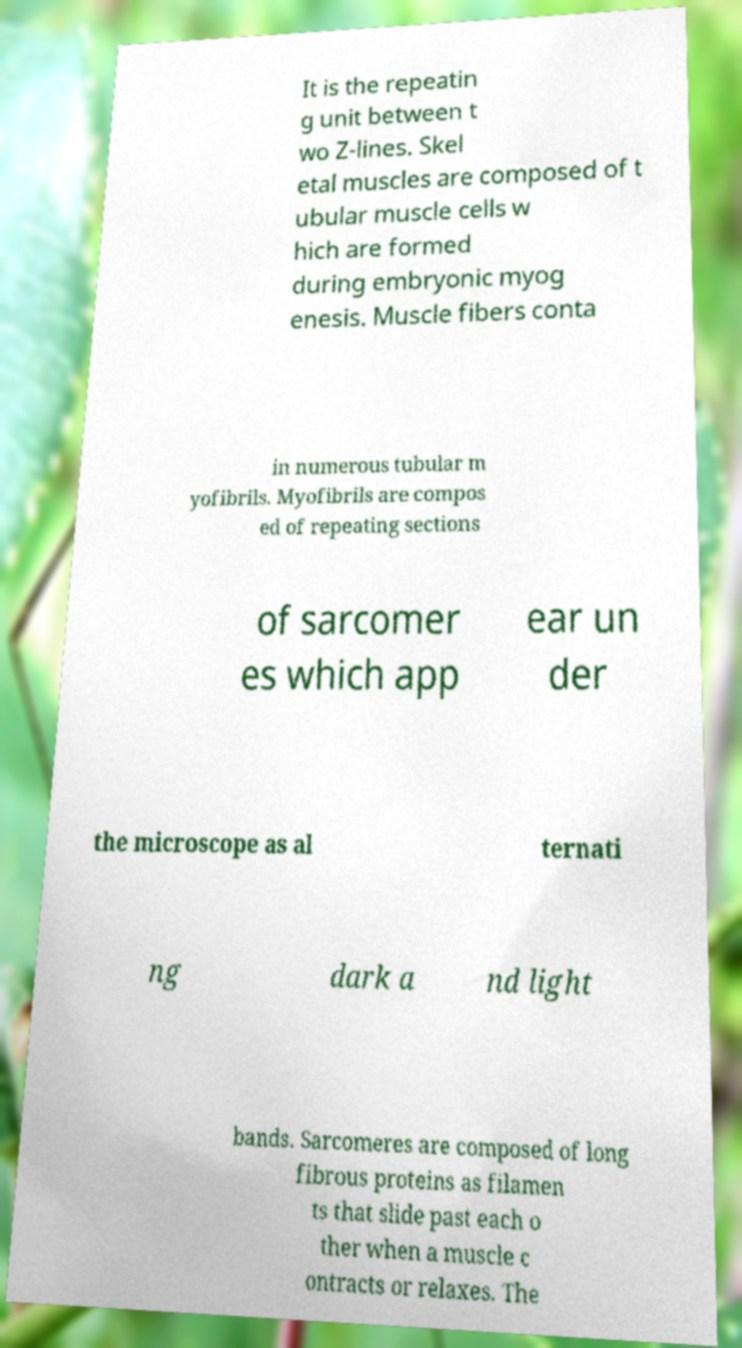Could you extract and type out the text from this image? It is the repeatin g unit between t wo Z-lines. Skel etal muscles are composed of t ubular muscle cells w hich are formed during embryonic myog enesis. Muscle fibers conta in numerous tubular m yofibrils. Myofibrils are compos ed of repeating sections of sarcomer es which app ear un der the microscope as al ternati ng dark a nd light bands. Sarcomeres are composed of long fibrous proteins as filamen ts that slide past each o ther when a muscle c ontracts or relaxes. The 